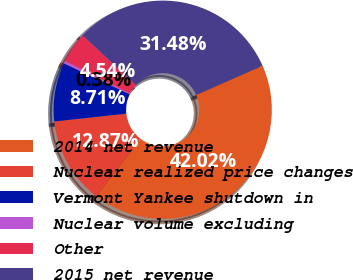Convert chart to OTSL. <chart><loc_0><loc_0><loc_500><loc_500><pie_chart><fcel>2014 net revenue<fcel>Nuclear realized price changes<fcel>Vermont Yankee shutdown in<fcel>Nuclear volume excluding<fcel>Other<fcel>2015 net revenue<nl><fcel>42.02%<fcel>12.87%<fcel>8.71%<fcel>0.38%<fcel>4.54%<fcel>31.48%<nl></chart> 